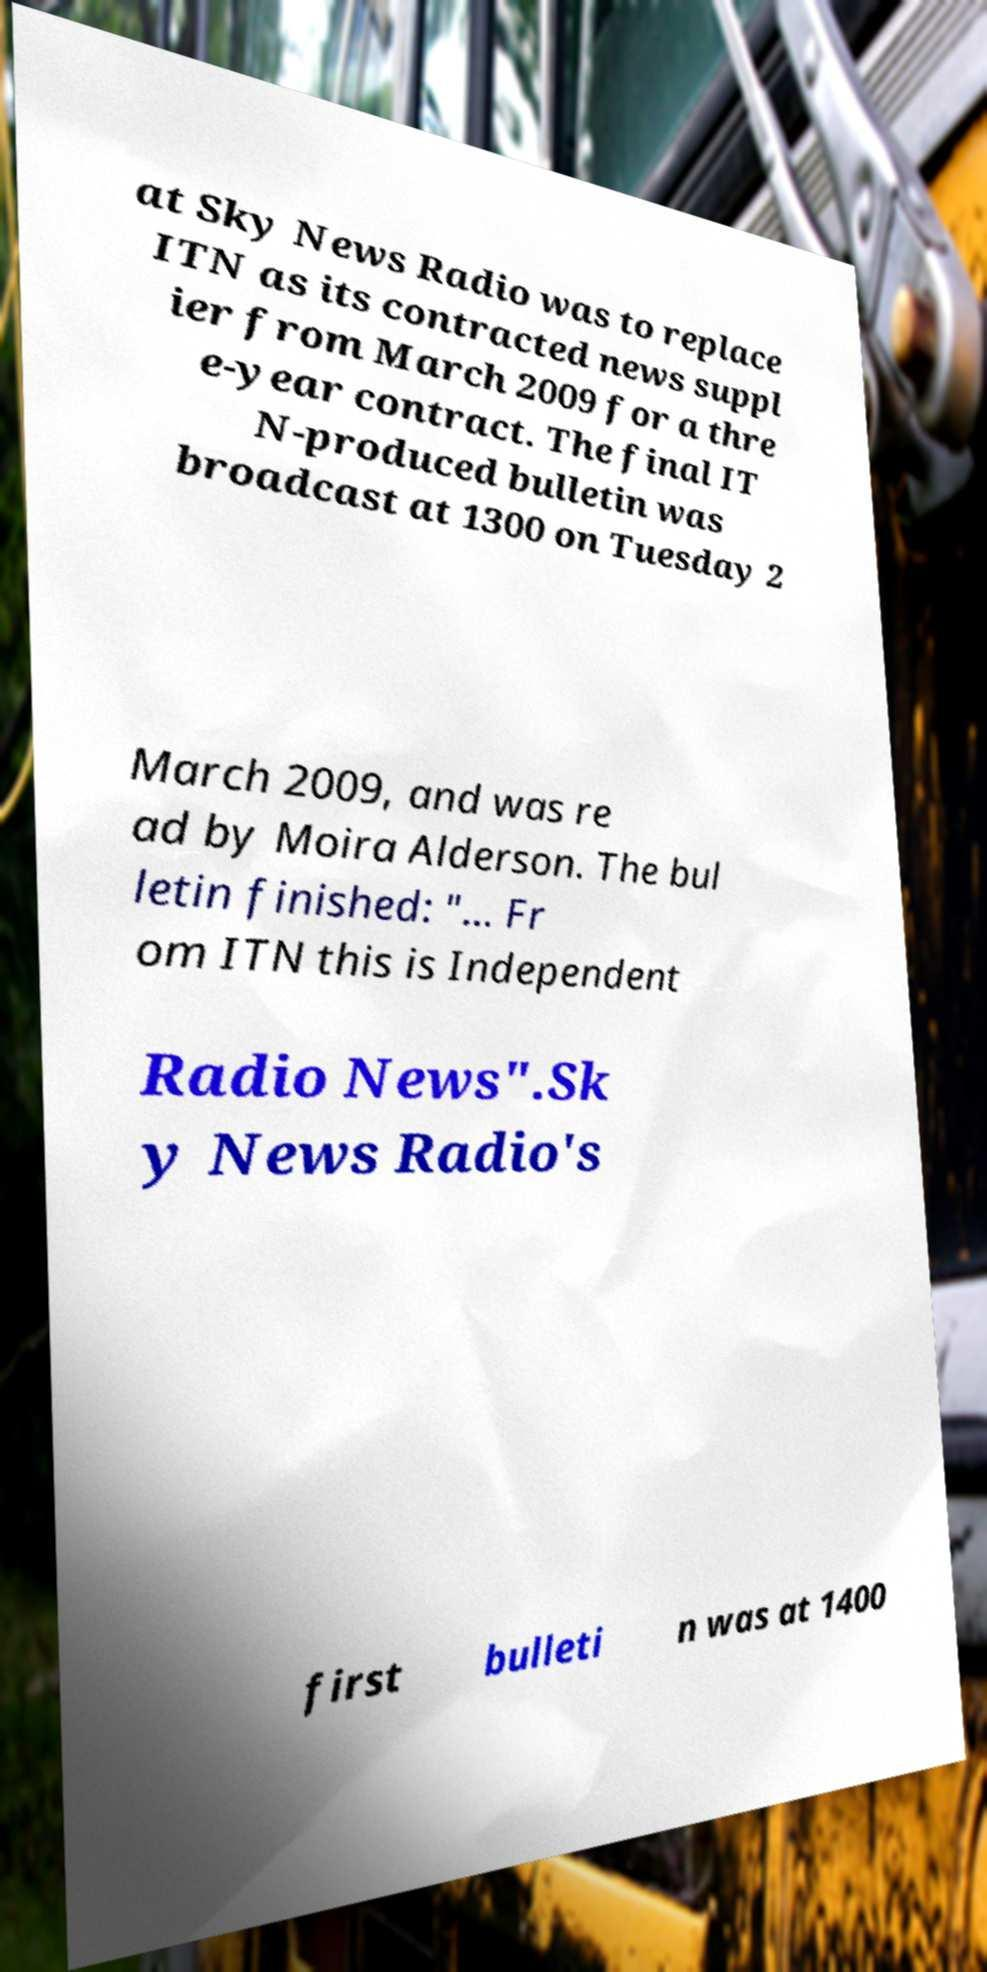Can you read and provide the text displayed in the image?This photo seems to have some interesting text. Can you extract and type it out for me? at Sky News Radio was to replace ITN as its contracted news suppl ier from March 2009 for a thre e-year contract. The final IT N-produced bulletin was broadcast at 1300 on Tuesday 2 March 2009, and was re ad by Moira Alderson. The bul letin finished: "... Fr om ITN this is Independent Radio News".Sk y News Radio's first bulleti n was at 1400 